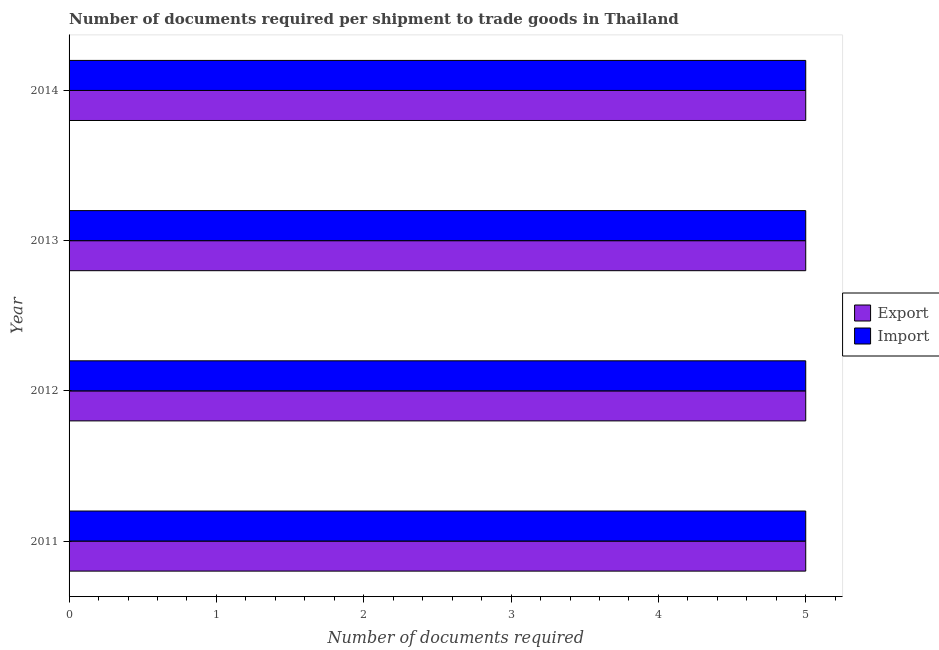How many different coloured bars are there?
Your answer should be very brief. 2. Are the number of bars per tick equal to the number of legend labels?
Your answer should be compact. Yes. How many bars are there on the 1st tick from the top?
Offer a very short reply. 2. How many bars are there on the 4th tick from the bottom?
Your answer should be compact. 2. In how many cases, is the number of bars for a given year not equal to the number of legend labels?
Your answer should be compact. 0. What is the number of documents required to export goods in 2011?
Offer a very short reply. 5. Across all years, what is the maximum number of documents required to import goods?
Provide a short and direct response. 5. Across all years, what is the minimum number of documents required to export goods?
Your answer should be compact. 5. What is the total number of documents required to import goods in the graph?
Make the answer very short. 20. What is the difference between the number of documents required to import goods in 2011 and that in 2014?
Make the answer very short. 0. What is the average number of documents required to import goods per year?
Ensure brevity in your answer.  5. In the year 2011, what is the difference between the number of documents required to import goods and number of documents required to export goods?
Your answer should be compact. 0. In how many years, is the number of documents required to import goods greater than 2.4 ?
Your answer should be compact. 4. What is the ratio of the number of documents required to export goods in 2011 to that in 2014?
Provide a short and direct response. 1. Is the difference between the number of documents required to export goods in 2011 and 2013 greater than the difference between the number of documents required to import goods in 2011 and 2013?
Offer a very short reply. No. What is the difference between the highest and the second highest number of documents required to import goods?
Offer a very short reply. 0. What is the difference between the highest and the lowest number of documents required to import goods?
Make the answer very short. 0. In how many years, is the number of documents required to export goods greater than the average number of documents required to export goods taken over all years?
Keep it short and to the point. 0. Is the sum of the number of documents required to import goods in 2011 and 2013 greater than the maximum number of documents required to export goods across all years?
Your answer should be very brief. Yes. What does the 1st bar from the top in 2014 represents?
Keep it short and to the point. Import. What does the 2nd bar from the bottom in 2011 represents?
Your answer should be very brief. Import. How many years are there in the graph?
Your answer should be very brief. 4. What is the difference between two consecutive major ticks on the X-axis?
Your response must be concise. 1. Does the graph contain any zero values?
Make the answer very short. No. Does the graph contain grids?
Provide a short and direct response. No. How many legend labels are there?
Give a very brief answer. 2. What is the title of the graph?
Offer a very short reply. Number of documents required per shipment to trade goods in Thailand. What is the label or title of the X-axis?
Keep it short and to the point. Number of documents required. What is the label or title of the Y-axis?
Make the answer very short. Year. What is the Number of documents required in Export in 2012?
Give a very brief answer. 5. What is the Number of documents required in Import in 2012?
Provide a succinct answer. 5. What is the Number of documents required of Import in 2013?
Offer a very short reply. 5. What is the Number of documents required of Export in 2014?
Your response must be concise. 5. Across all years, what is the maximum Number of documents required in Export?
Give a very brief answer. 5. Across all years, what is the maximum Number of documents required in Import?
Your answer should be very brief. 5. Across all years, what is the minimum Number of documents required in Export?
Offer a terse response. 5. Across all years, what is the minimum Number of documents required in Import?
Keep it short and to the point. 5. What is the total Number of documents required in Export in the graph?
Ensure brevity in your answer.  20. What is the total Number of documents required of Import in the graph?
Give a very brief answer. 20. What is the difference between the Number of documents required in Import in 2011 and that in 2013?
Offer a terse response. 0. What is the difference between the Number of documents required of Export in 2012 and that in 2013?
Make the answer very short. 0. What is the difference between the Number of documents required of Export in 2012 and that in 2014?
Give a very brief answer. 0. What is the difference between the Number of documents required in Import in 2012 and that in 2014?
Give a very brief answer. 0. What is the difference between the Number of documents required of Export in 2013 and that in 2014?
Keep it short and to the point. 0. What is the difference between the Number of documents required in Import in 2013 and that in 2014?
Your answer should be very brief. 0. What is the difference between the Number of documents required in Export in 2011 and the Number of documents required in Import in 2012?
Offer a terse response. 0. What is the difference between the Number of documents required of Export in 2011 and the Number of documents required of Import in 2013?
Offer a terse response. 0. What is the difference between the Number of documents required in Export in 2012 and the Number of documents required in Import in 2013?
Keep it short and to the point. 0. What is the average Number of documents required in Import per year?
Make the answer very short. 5. In the year 2011, what is the difference between the Number of documents required of Export and Number of documents required of Import?
Provide a short and direct response. 0. What is the ratio of the Number of documents required of Export in 2011 to that in 2012?
Your response must be concise. 1. What is the ratio of the Number of documents required in Import in 2011 to that in 2012?
Ensure brevity in your answer.  1. What is the ratio of the Number of documents required in Export in 2011 to that in 2013?
Ensure brevity in your answer.  1. What is the ratio of the Number of documents required of Import in 2011 to that in 2013?
Provide a short and direct response. 1. What is the ratio of the Number of documents required in Import in 2012 to that in 2014?
Provide a succinct answer. 1. What is the ratio of the Number of documents required in Export in 2013 to that in 2014?
Give a very brief answer. 1. What is the ratio of the Number of documents required in Import in 2013 to that in 2014?
Keep it short and to the point. 1. What is the difference between the highest and the second highest Number of documents required in Export?
Make the answer very short. 0. 